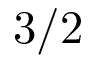Convert formula to latex. <formula><loc_0><loc_0><loc_500><loc_500>3 / 2</formula> 